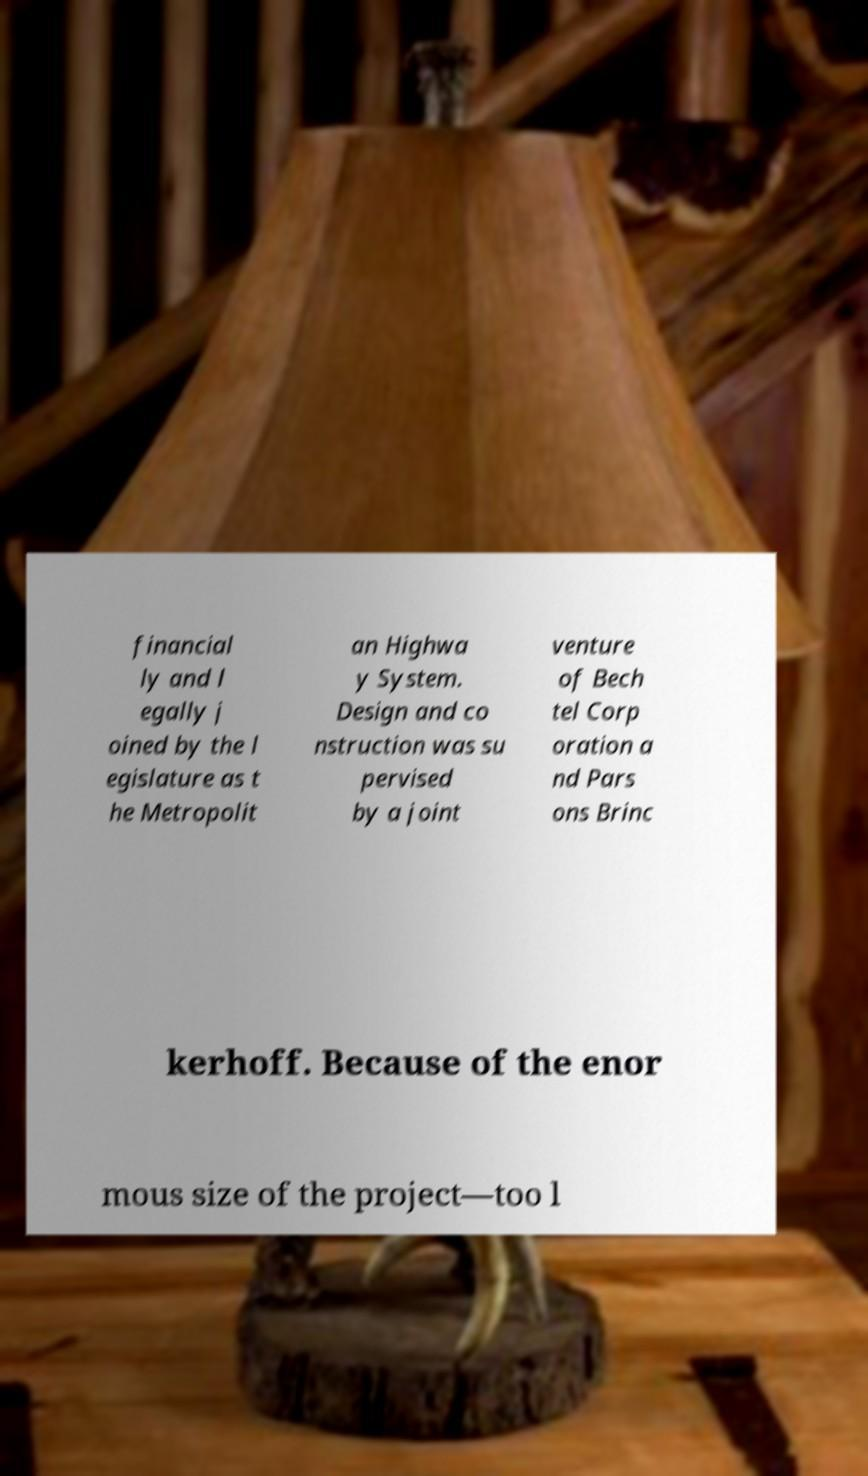Please read and relay the text visible in this image. What does it say? financial ly and l egally j oined by the l egislature as t he Metropolit an Highwa y System. Design and co nstruction was su pervised by a joint venture of Bech tel Corp oration a nd Pars ons Brinc kerhoff. Because of the enor mous size of the project—too l 